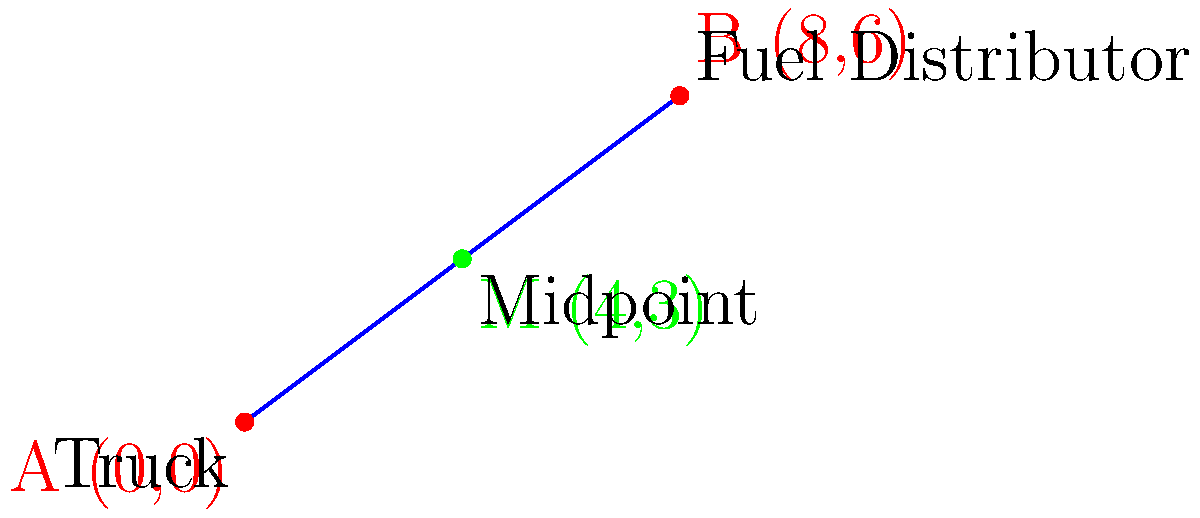A truck driver is currently at coordinates (0,0) and needs to reach the nearest fuel distributor located at (8,6). To plan the journey efficiently, the driver wants to find the coordinates of the midpoint between their current location and the fuel distributor. What are the coordinates of this midpoint? To find the midpoint between two points, we can use the midpoint formula:

$$ M_x = \frac{x_1 + x_2}{2}, \quad M_y = \frac{y_1 + y_2}{2} $$

Where $(x_1, y_1)$ is the first point and $(x_2, y_2)$ is the second point.

Given:
- Truck's location (Point A): $(0, 0)$
- Fuel distributor's location (Point B): $(8, 6)$

Step 1: Calculate the x-coordinate of the midpoint:
$$ M_x = \frac{0 + 8}{2} = \frac{8}{2} = 4 $$

Step 2: Calculate the y-coordinate of the midpoint:
$$ M_y = \frac{0 + 6}{2} = \frac{6}{2} = 3 $$

Therefore, the coordinates of the midpoint (M) are (4, 3).
Answer: (4, 3) 